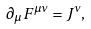Convert formula to latex. <formula><loc_0><loc_0><loc_500><loc_500>\partial _ { \mu } F ^ { \mu \nu } = J ^ { \nu } ,</formula> 